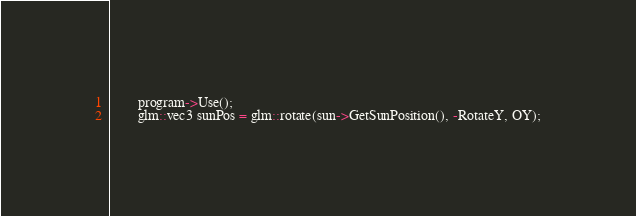<code> <loc_0><loc_0><loc_500><loc_500><_C++_>		program->Use();
		glm::vec3 sunPos = glm::rotate(sun->GetSunPosition(), -RotateY, OY);</code> 